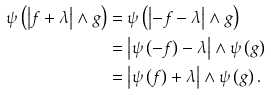<formula> <loc_0><loc_0><loc_500><loc_500>\psi \left ( \left | f + \lambda \right | \wedge g \right ) & = \psi \left ( \left | - f - \lambda \right | \wedge g \right ) \\ & = \left | \psi \left ( - f \right ) - \lambda \right | \wedge \psi \left ( g \right ) \\ & = \left | \psi \left ( f \right ) + \lambda \right | \wedge \psi \left ( g \right ) .</formula> 